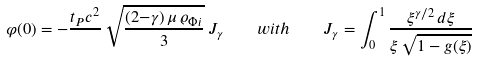Convert formula to latex. <formula><loc_0><loc_0><loc_500><loc_500>\varphi ( 0 ) = - \frac { t _ { P } c ^ { 2 } } { } \, \sqrt { \frac { ( 2 { - } \gamma ) \, \mu \, \varrho _ { \Phi i } } { 3 } } \, J _ { \gamma } \quad w i t h \quad J _ { \gamma } = \int _ { 0 } ^ { 1 } \frac { \xi ^ { \gamma / 2 } \, d \xi } { \xi \, \sqrt { 1 - g ( \xi ) } }</formula> 